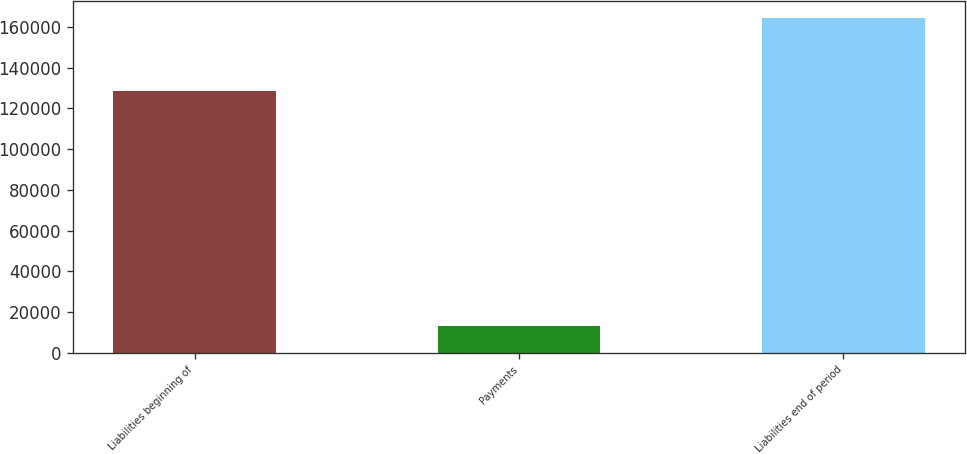<chart> <loc_0><loc_0><loc_500><loc_500><bar_chart><fcel>Liabilities beginning of<fcel>Payments<fcel>Liabilities end of period<nl><fcel>128330<fcel>13075<fcel>164280<nl></chart> 